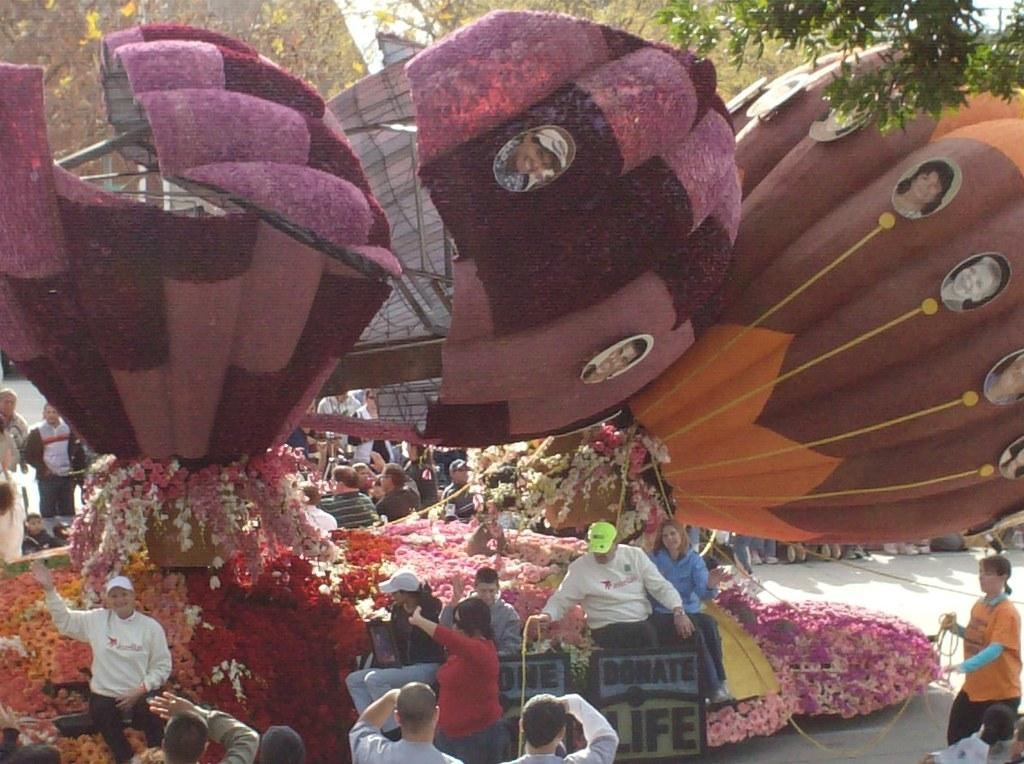What can be seen in the image related to outdoor activities? In the image, there are parachutes, trees, and people, which are related to outdoor activities. What type of visuals are present in the image? The image contains pictures, flowers, and people. What objects can be seen in the image? There are boards and objects visible in the image. Are there any people holding objects in the image? Yes, some people are holding objects in the image. Where is the meeting taking place in the image? There is no meeting present in the image; it features parachutes, pictures, flowers, people, boards, trees, and objects. What type of feather can be seen on the people in the image? There are no feathers visible on the people in the image. 